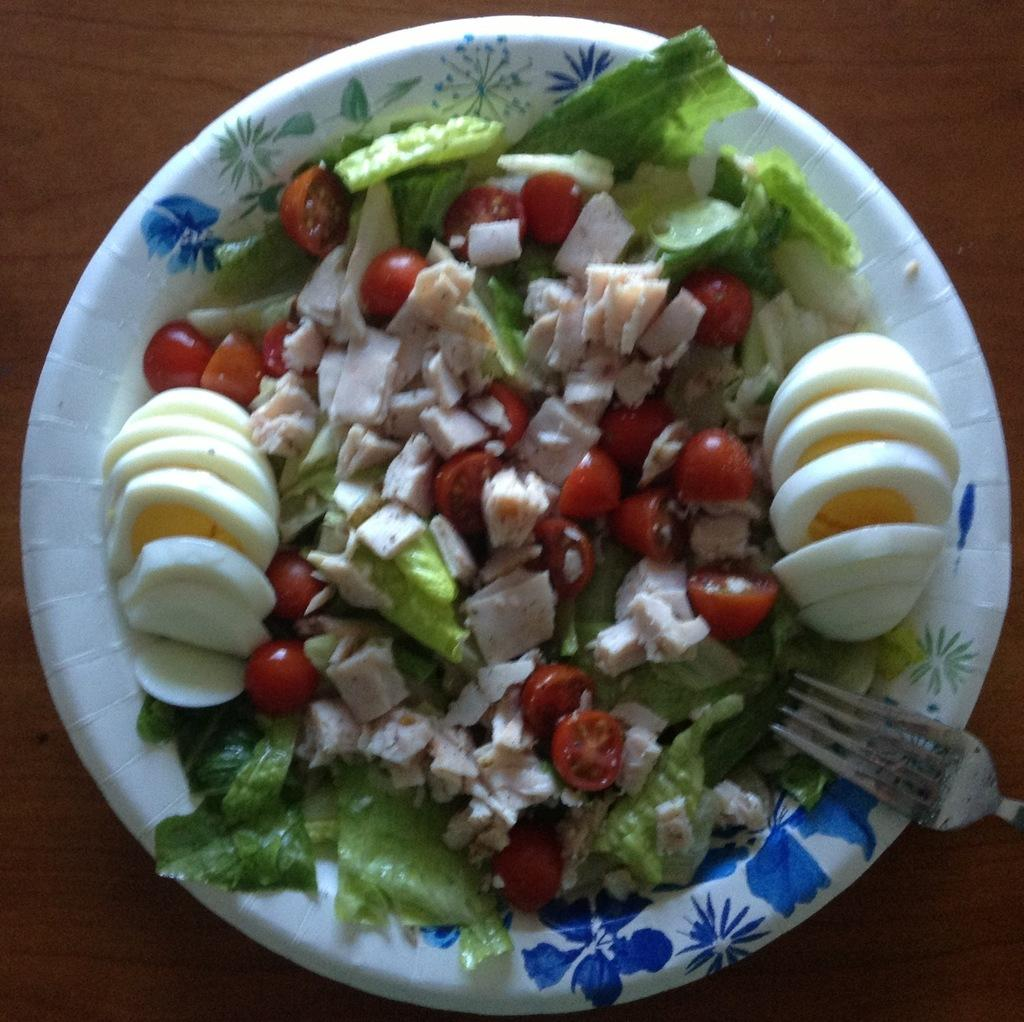What is present in the image related to food? There is food in the image. What utensil can be seen in the image? There is a fork in the image. Where is the fork located in the image? The fork is in a plate. What type of toys are present in the image? There are no toys present in the image. 